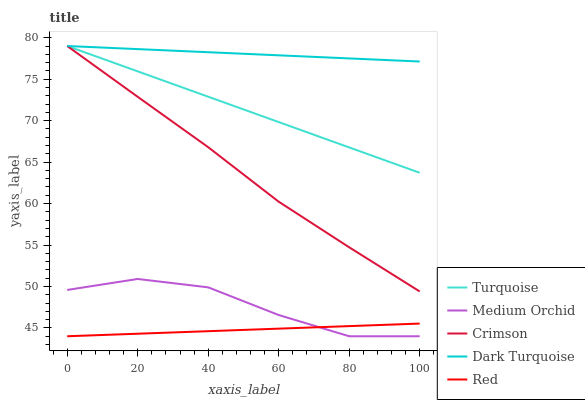Does Red have the minimum area under the curve?
Answer yes or no. Yes. Does Dark Turquoise have the maximum area under the curve?
Answer yes or no. Yes. Does Turquoise have the minimum area under the curve?
Answer yes or no. No. Does Turquoise have the maximum area under the curve?
Answer yes or no. No. Is Dark Turquoise the smoothest?
Answer yes or no. Yes. Is Medium Orchid the roughest?
Answer yes or no. Yes. Is Turquoise the smoothest?
Answer yes or no. No. Is Turquoise the roughest?
Answer yes or no. No. Does Medium Orchid have the lowest value?
Answer yes or no. Yes. Does Turquoise have the lowest value?
Answer yes or no. No. Does Turquoise have the highest value?
Answer yes or no. Yes. Does Medium Orchid have the highest value?
Answer yes or no. No. Is Medium Orchid less than Dark Turquoise?
Answer yes or no. Yes. Is Dark Turquoise greater than Red?
Answer yes or no. Yes. Does Turquoise intersect Crimson?
Answer yes or no. Yes. Is Turquoise less than Crimson?
Answer yes or no. No. Is Turquoise greater than Crimson?
Answer yes or no. No. Does Medium Orchid intersect Dark Turquoise?
Answer yes or no. No. 